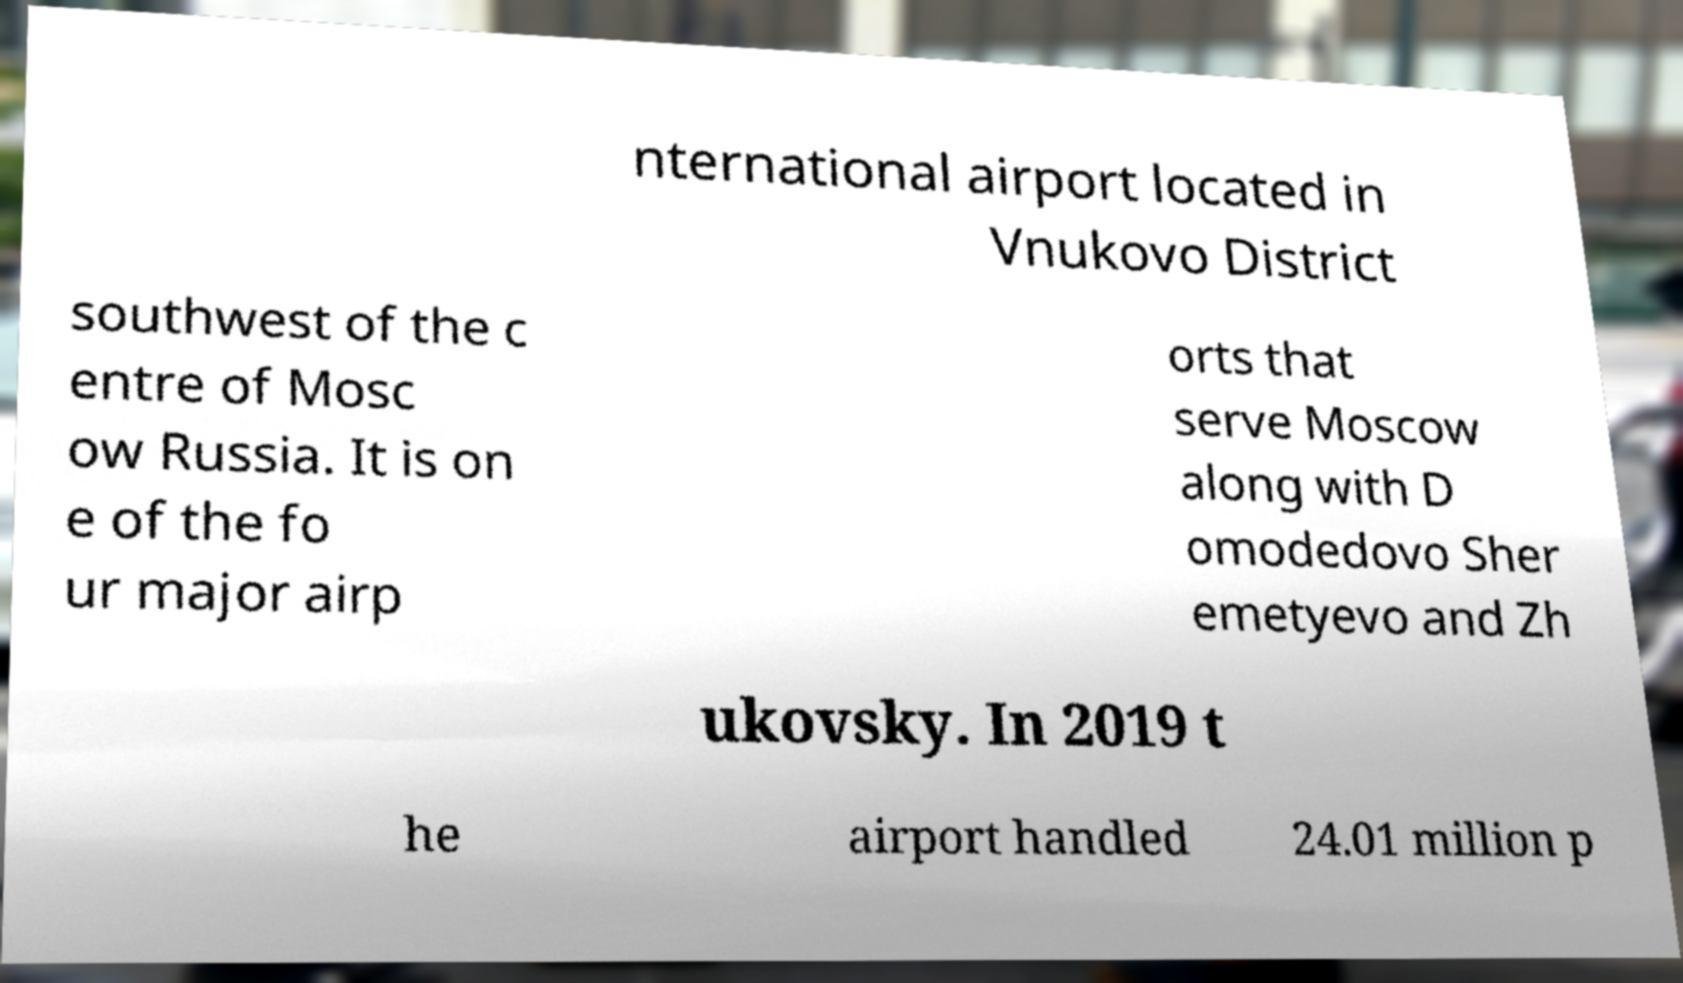Could you assist in decoding the text presented in this image and type it out clearly? nternational airport located in Vnukovo District southwest of the c entre of Mosc ow Russia. It is on e of the fo ur major airp orts that serve Moscow along with D omodedovo Sher emetyevo and Zh ukovsky. In 2019 t he airport handled 24.01 million p 